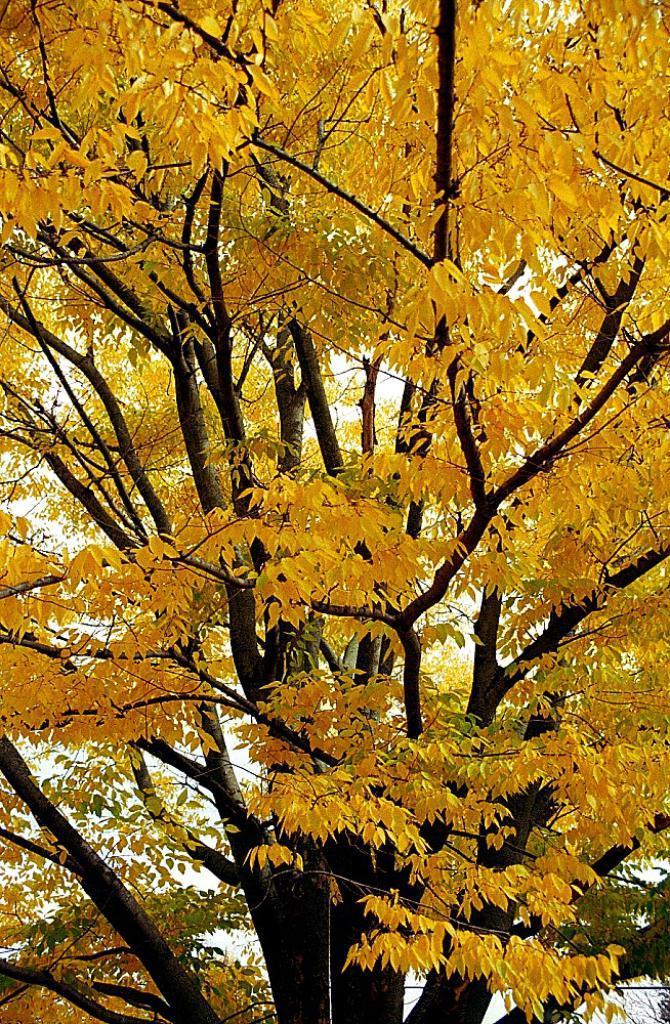How would you summarize this image in a sentence or two? In this image we can see a tree. There are yellow color leaves and few are green in color in the image. 